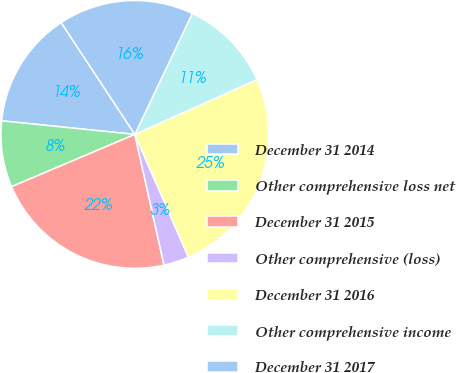<chart> <loc_0><loc_0><loc_500><loc_500><pie_chart><fcel>December 31 2014<fcel>Other comprehensive loss net<fcel>December 31 2015<fcel>Other comprehensive (loss)<fcel>December 31 2016<fcel>Other comprehensive income<fcel>December 31 2017<nl><fcel>14.11%<fcel>8.0%<fcel>22.11%<fcel>3.06%<fcel>25.17%<fcel>11.22%<fcel>16.33%<nl></chart> 